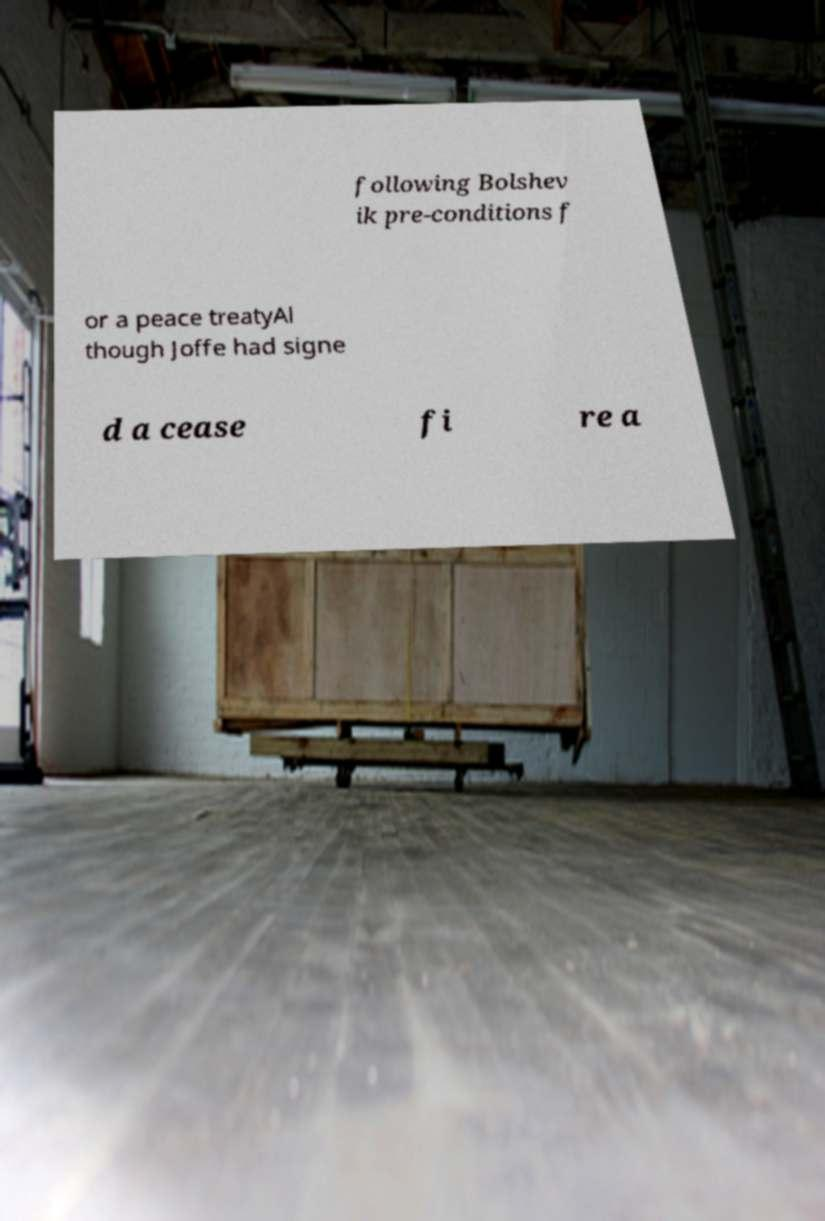Can you read and provide the text displayed in the image?This photo seems to have some interesting text. Can you extract and type it out for me? following Bolshev ik pre-conditions f or a peace treatyAl though Joffe had signe d a cease fi re a 